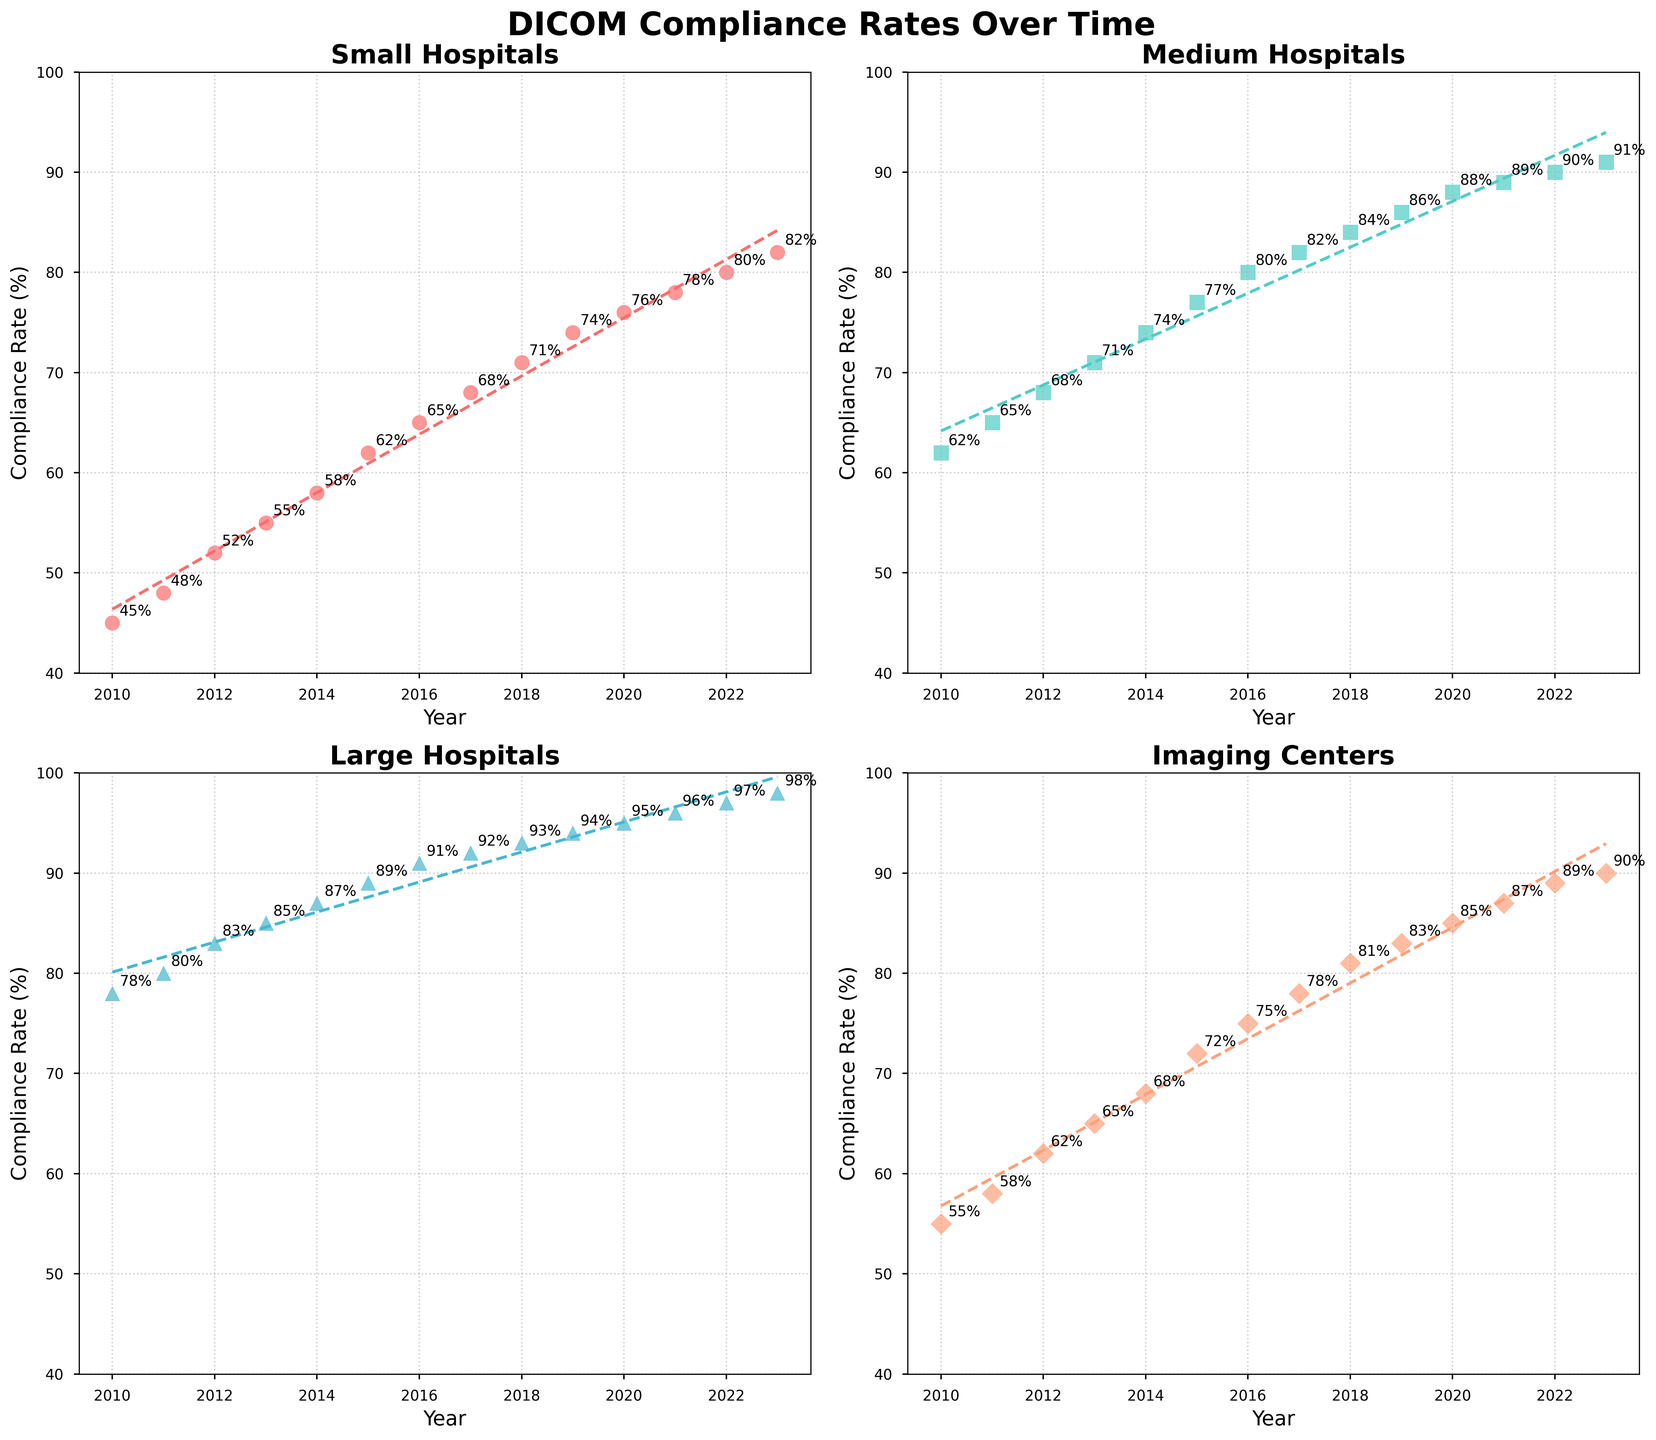What is the compliance rate for small hospitals in 2013? The compliance rate for small hospitals in 2013 can be found directly from the scatter plot for small hospitals. Locate the point for the year 2013 on the x-axis and read the corresponding y-axis value.
Answer: 55% Which category saw the highest compliance rate in 2023? To find the category with the highest compliance rate in 2023, compare the y-axis values for all categories in the year 2023. The highest rate corresponds to the largest y-axis value among small hospitals, medium hospitals, large hospitals, and imaging centers.
Answer: Large Hospitals What is the difference in compliance rates between imaging centers and small hospitals in 2016? Find the compliance rates for both imaging centers and small hospitals in 2016 from their respective scatter plots. For imaging centers, it's 75%. For small hospitals, it's 65%. Subtract the compliance rate for small hospitals from that of imaging centers: 75% - 65% = 10%.
Answer: 10% Which category has the steepest trendline? Compare the slopes of the trendlines fitted to each scatter plot. The category with the steepest trendline will have the largest slope.
Answer: Large Hospitals What is the average compliance rate for medium hospitals over the years 2010-2023? Sum the compliance rates for medium hospitals from 2010 to 2023 and then divide by the number of years (14). (62 + 65 + 68 + 71 + 74 + 77 + 80 + 82 + 84 + 86 + 88 + 89 + 90 + 91) / 14 = 77.
Answer: 77% In what year did large hospitals achieve a 90% compliance rate? Locate the point on the scatter plot for large hospitals that corresponds to a 90% compliance rate on the y-axis and read the corresponding year on the x-axis.
Answer: 2016 Which category exhibits the lowest compliance rate in any given year within the time frame? Identify the lowest compliance rate by looking at the minimum y-axis value across all scatter plots from 2010 to 2023. Compare values for small hospitals, medium hospitals, large hospitals, and imaging centers.
Answer: Small Hospitals in 2010 Are there any categories with compliance rates that never fall below 60% across the years? Check all the scatter plots for points below the 60% compliance rate. If a category has no points below 60% across the years, it meets the criteria.
Answer: Large Hospitals, Imaging Centers By how many percentage points did small hospitals' compliance rate increase from 2015 to 2018? Find the compliance rates for small hospitals in 2015 and 2018: for 2015 it's 62%, and for 2018 it's 71%. Subtract the 2015 rate from the 2018 rate: 71% - 62% = 9%.
Answer: 9% Which two categories have the most similar compliance rates in 2022? Compare the compliance rates for all categories in 2022 and identify the two categories with the closest y-axis values.
Answer: Medium Hospitals and Imaging Centers 